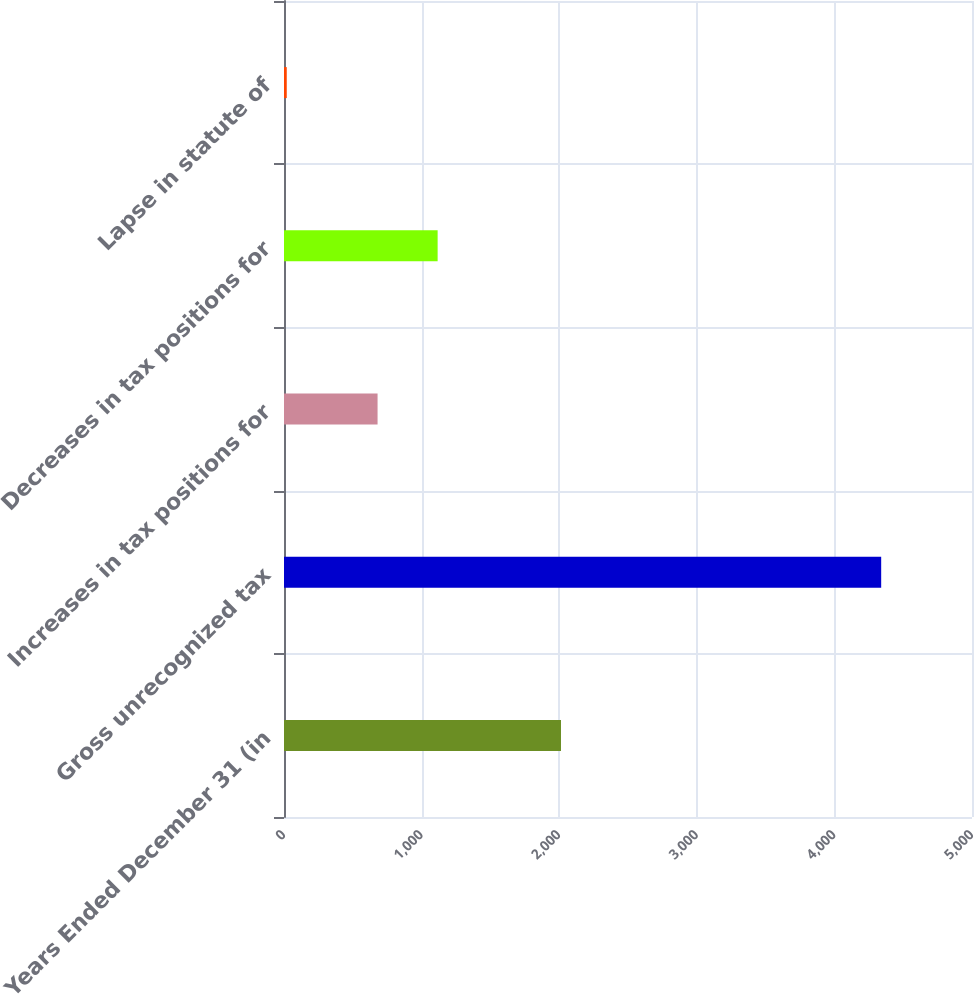Convert chart to OTSL. <chart><loc_0><loc_0><loc_500><loc_500><bar_chart><fcel>Years Ended December 31 (in<fcel>Gross unrecognized tax<fcel>Increases in tax positions for<fcel>Decreases in tax positions for<fcel>Lapse in statute of<nl><fcel>2013<fcel>4340<fcel>680<fcel>1116.5<fcel>20<nl></chart> 